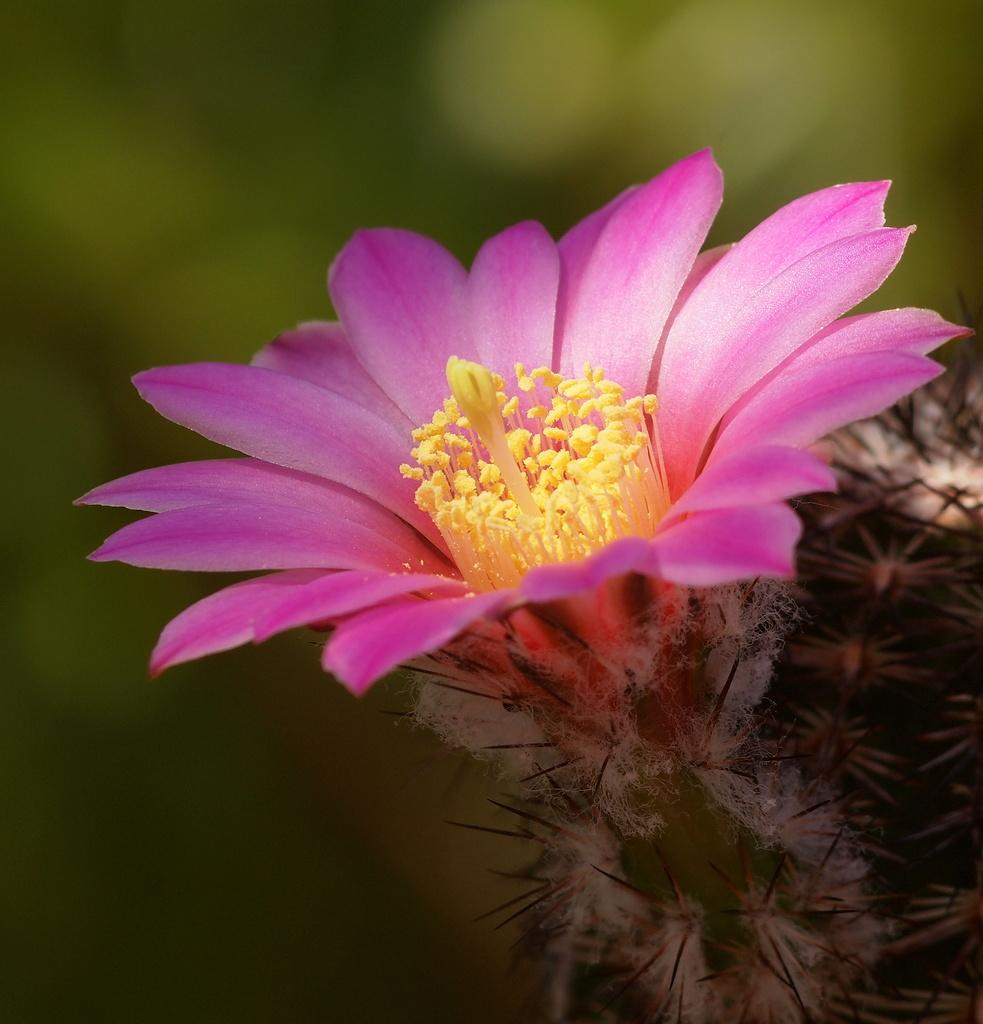What is the main subject of the image? There is a flower in the image. Can you describe the colors of the flower? The flower has pink and yellow colors. Where is the flower located? The flower is on a plant. What can be seen in the background of the image? The background of the image is green and blurry. Is there a judge standing next to the flower in the image? No, there is no judge present in the image. What type of mint can be seen growing alongside the flower in the image? There is no mint visible in the image; it only features a flower on a plant. 